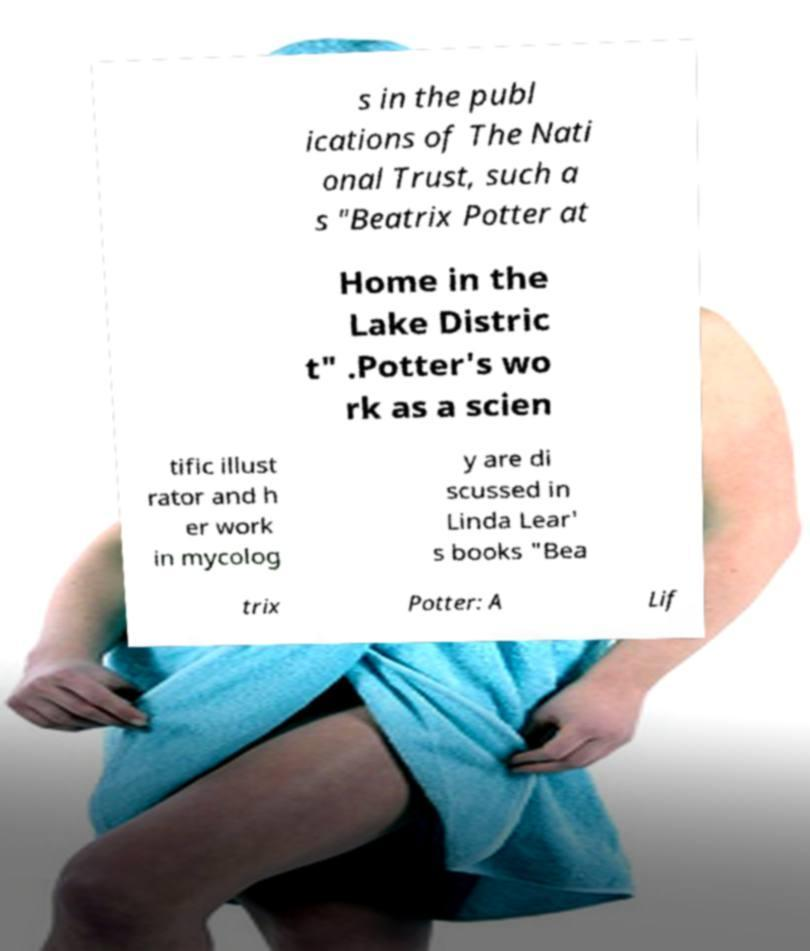There's text embedded in this image that I need extracted. Can you transcribe it verbatim? s in the publ ications of The Nati onal Trust, such a s "Beatrix Potter at Home in the Lake Distric t" .Potter's wo rk as a scien tific illust rator and h er work in mycolog y are di scussed in Linda Lear' s books "Bea trix Potter: A Lif 